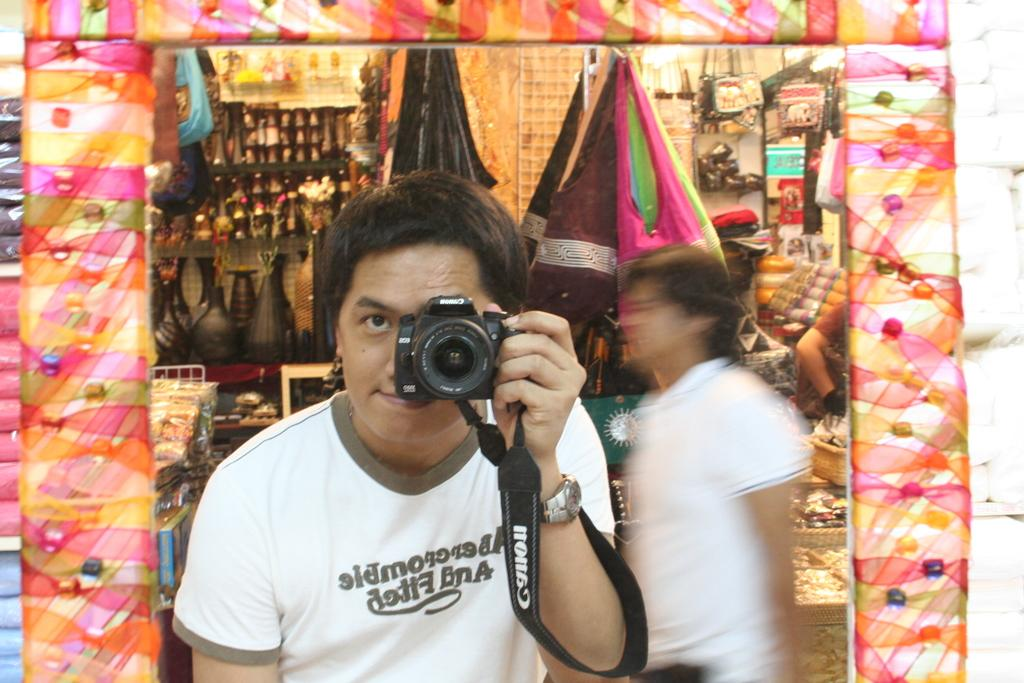What is the man in the image holding? The man in the image is holding a camera. Can you describe the other person in the image? There is another man standing in the image. What can be seen in the background of the image? There is a store visible in the background of the image. What type of juice is being squeezed by the man in the image? There is no juice or squeezing activity present in the image. 